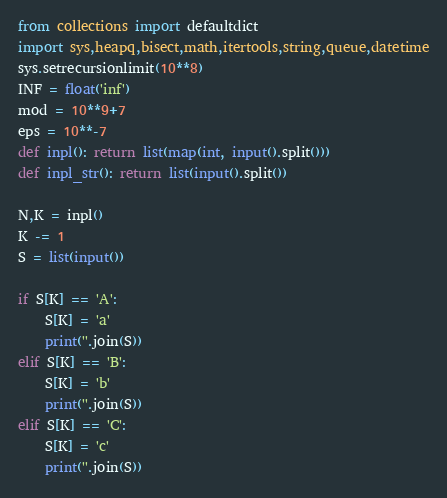Convert code to text. <code><loc_0><loc_0><loc_500><loc_500><_Python_>from collections import defaultdict
import sys,heapq,bisect,math,itertools,string,queue,datetime
sys.setrecursionlimit(10**8)
INF = float('inf')
mod = 10**9+7
eps = 10**-7
def inpl(): return list(map(int, input().split()))
def inpl_str(): return list(input().split())

N,K = inpl()
K -= 1
S = list(input())

if S[K] == 'A':
    S[K] = 'a'
    print(''.join(S))
elif S[K] == 'B':
    S[K] = 'b'
    print(''.join(S))
elif S[K] == 'C':
    S[K] = 'c'
    print(''.join(S))
</code> 